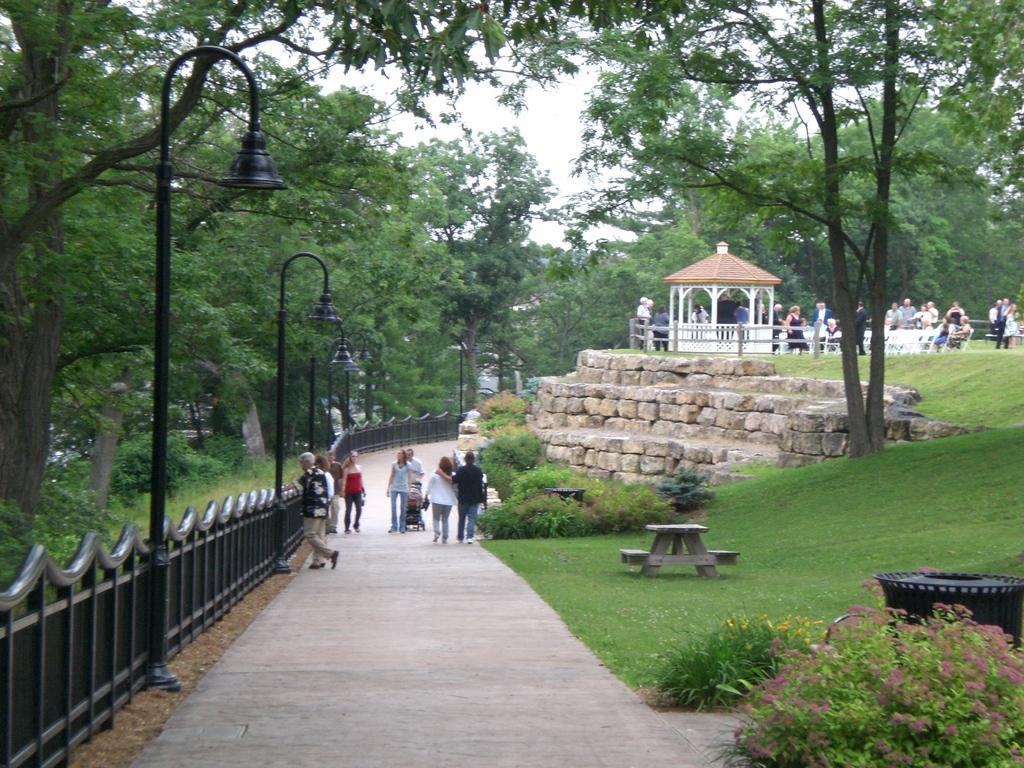Can you describe this image briefly? In this picture, we can see a few people, and we can see path, poles, lights, fencing, ground with some objects, grass, trees, plants, shed, and the sky. 